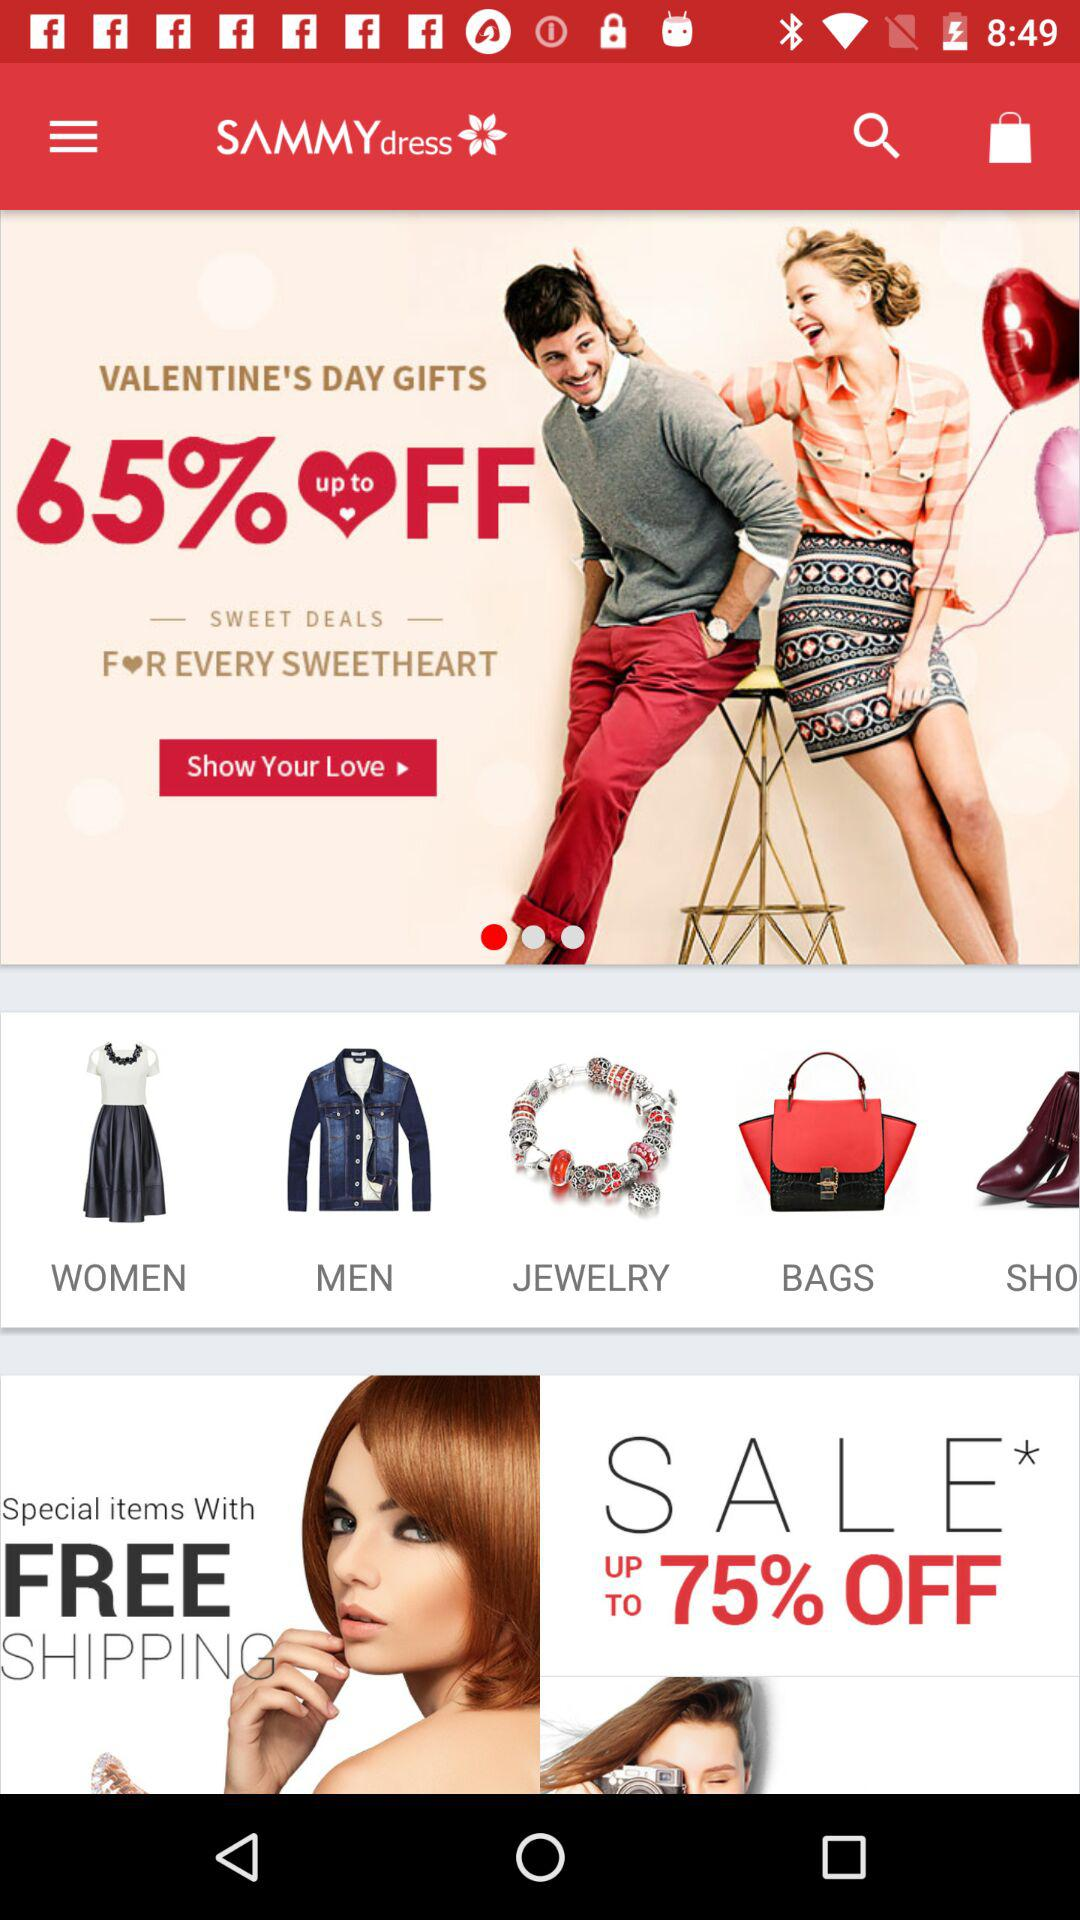How can the user contact "Sammydress" for support?
When the provided information is insufficient, respond with <no answer>. <no answer> 